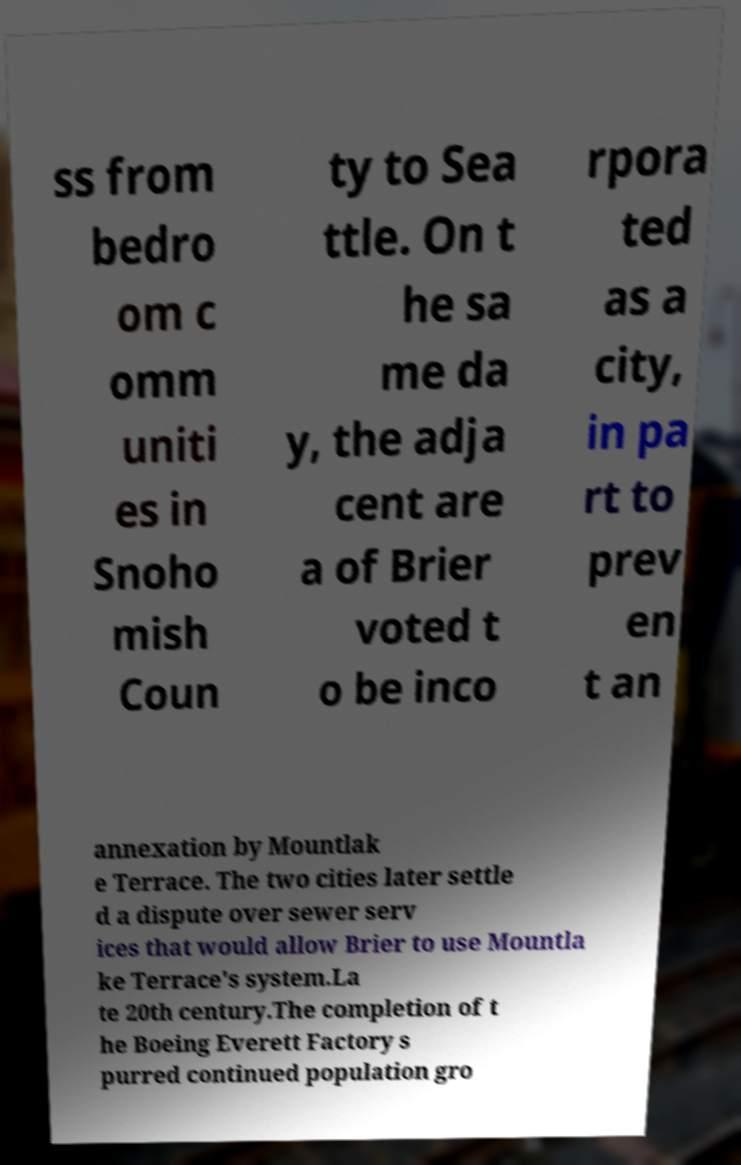Could you assist in decoding the text presented in this image and type it out clearly? ss from bedro om c omm uniti es in Snoho mish Coun ty to Sea ttle. On t he sa me da y, the adja cent are a of Brier voted t o be inco rpora ted as a city, in pa rt to prev en t an annexation by Mountlak e Terrace. The two cities later settle d a dispute over sewer serv ices that would allow Brier to use Mountla ke Terrace's system.La te 20th century.The completion of t he Boeing Everett Factory s purred continued population gro 